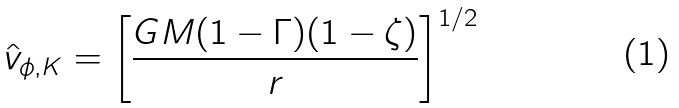<formula> <loc_0><loc_0><loc_500><loc_500>\hat { v } _ { \phi , K } = \left [ \frac { G M ( 1 - \Gamma ) ( 1 - \zeta ) } { r } \right ] ^ { 1 / 2 } \,</formula> 